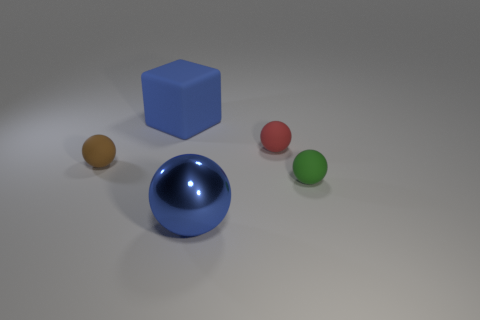How many light sources can you infer from the scene? Based on the single direction of the shadows cast by the cube and the spheres, it can be inferred that there is one primary light source in the scene. The diffused nature of the shadows implies that the light source is not overly harsh or direct. 